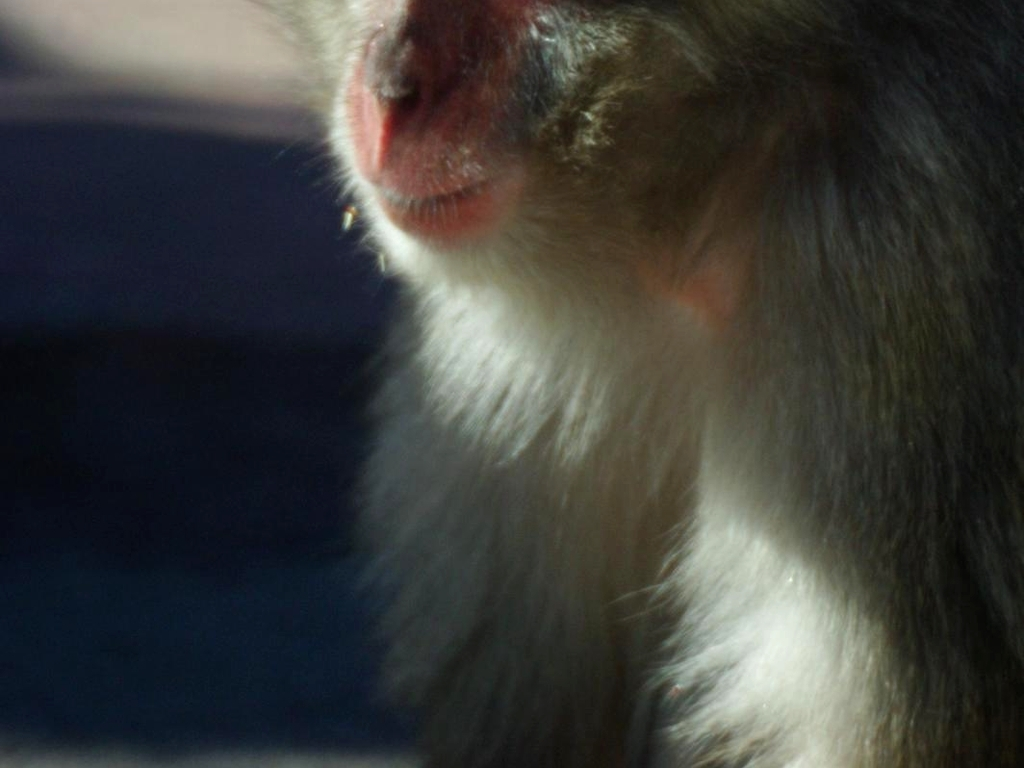What details can we observe about the subject's texture and color? The subject has a rich coat with various shades of color, from dark at the roots transitioning to lighter hues. The texture appears to be soft and dense, characteristic of a well-kept fur. 